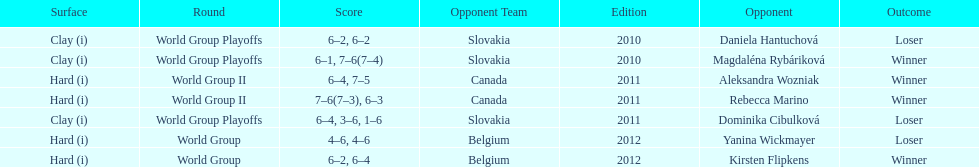What was the next game listed after the world group ii rounds? World Group Playoffs. Would you be able to parse every entry in this table? {'header': ['Surface', 'Round', 'Score', 'Opponent Team', 'Edition', 'Opponent', 'Outcome'], 'rows': [['Clay (i)', 'World Group Playoffs', '6–2, 6–2', 'Slovakia', '2010', 'Daniela Hantuchová', 'Loser'], ['Clay (i)', 'World Group Playoffs', '6–1, 7–6(7–4)', 'Slovakia', '2010', 'Magdaléna Rybáriková', 'Winner'], ['Hard (i)', 'World Group II', '6–4, 7–5', 'Canada', '2011', 'Aleksandra Wozniak', 'Winner'], ['Hard (i)', 'World Group II', '7–6(7–3), 6–3', 'Canada', '2011', 'Rebecca Marino', 'Winner'], ['Clay (i)', 'World Group Playoffs', '6–4, 3–6, 1–6', 'Slovakia', '2011', 'Dominika Cibulková', 'Loser'], ['Hard (i)', 'World Group', '4–6, 4–6', 'Belgium', '2012', 'Yanina Wickmayer', 'Loser'], ['Hard (i)', 'World Group', '6–2, 6–4', 'Belgium', '2012', 'Kirsten Flipkens', 'Winner']]} 